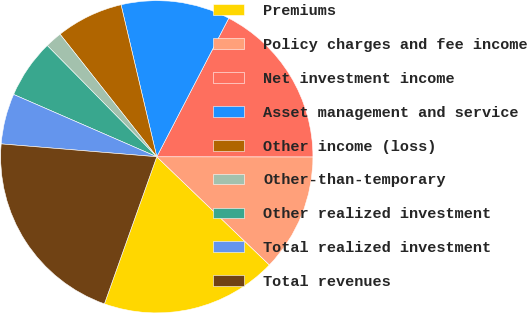Convert chart. <chart><loc_0><loc_0><loc_500><loc_500><pie_chart><fcel>Premiums<fcel>Policy charges and fee income<fcel>Net investment income<fcel>Asset management and service<fcel>Other income (loss)<fcel>Other-than-temporary<fcel>Other realized investment<fcel>Total realized investment<fcel>Total revenues<nl><fcel>18.26%<fcel>12.17%<fcel>17.39%<fcel>11.3%<fcel>6.96%<fcel>1.74%<fcel>6.09%<fcel>5.22%<fcel>20.87%<nl></chart> 